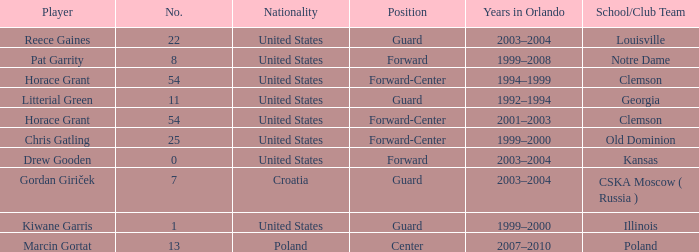What is Chris Gatling 's number? 25.0. 